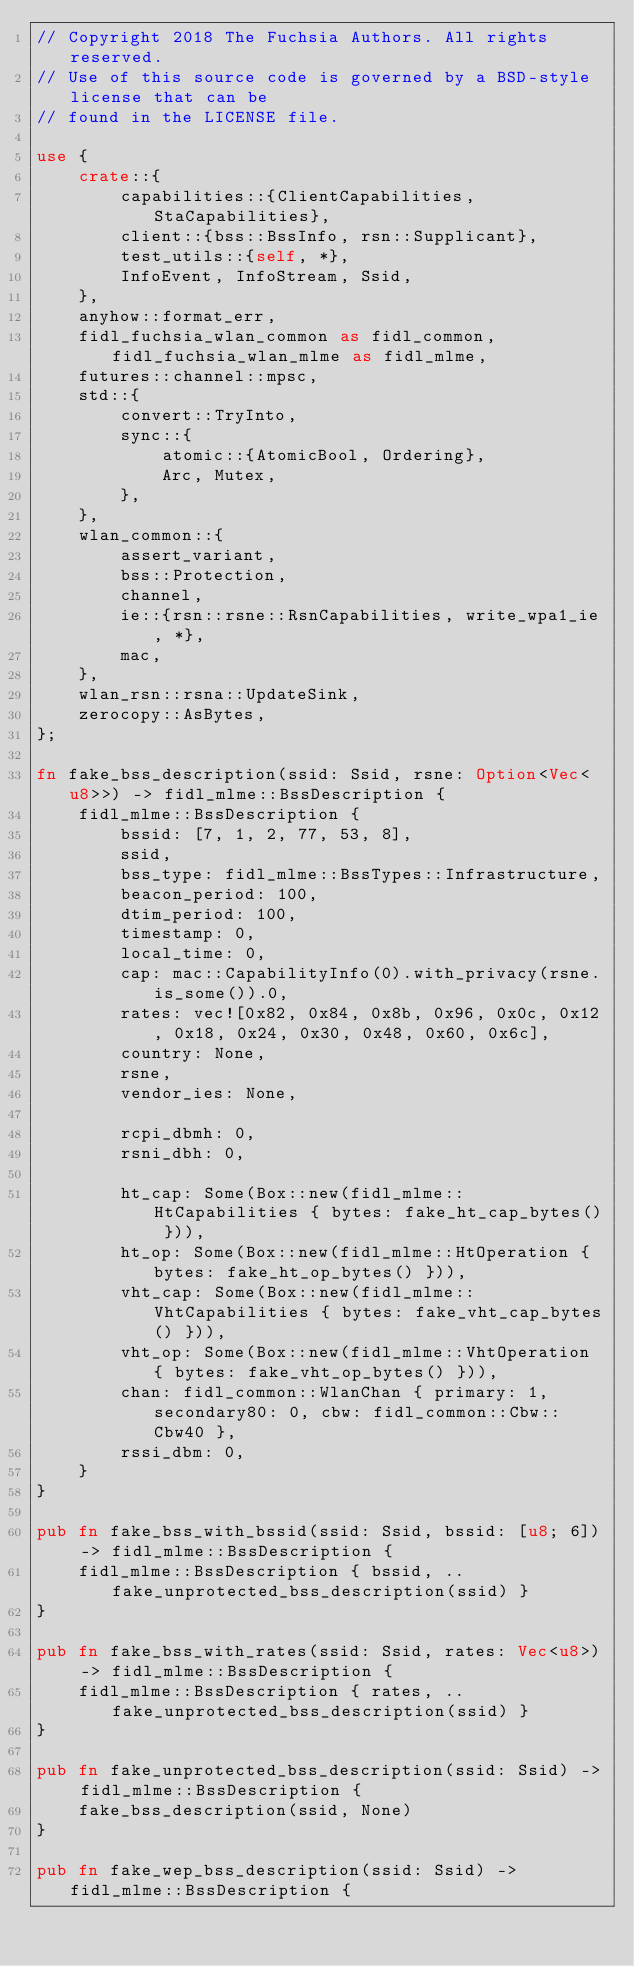<code> <loc_0><loc_0><loc_500><loc_500><_Rust_>// Copyright 2018 The Fuchsia Authors. All rights reserved.
// Use of this source code is governed by a BSD-style license that can be
// found in the LICENSE file.

use {
    crate::{
        capabilities::{ClientCapabilities, StaCapabilities},
        client::{bss::BssInfo, rsn::Supplicant},
        test_utils::{self, *},
        InfoEvent, InfoStream, Ssid,
    },
    anyhow::format_err,
    fidl_fuchsia_wlan_common as fidl_common, fidl_fuchsia_wlan_mlme as fidl_mlme,
    futures::channel::mpsc,
    std::{
        convert::TryInto,
        sync::{
            atomic::{AtomicBool, Ordering},
            Arc, Mutex,
        },
    },
    wlan_common::{
        assert_variant,
        bss::Protection,
        channel,
        ie::{rsn::rsne::RsnCapabilities, write_wpa1_ie, *},
        mac,
    },
    wlan_rsn::rsna::UpdateSink,
    zerocopy::AsBytes,
};

fn fake_bss_description(ssid: Ssid, rsne: Option<Vec<u8>>) -> fidl_mlme::BssDescription {
    fidl_mlme::BssDescription {
        bssid: [7, 1, 2, 77, 53, 8],
        ssid,
        bss_type: fidl_mlme::BssTypes::Infrastructure,
        beacon_period: 100,
        dtim_period: 100,
        timestamp: 0,
        local_time: 0,
        cap: mac::CapabilityInfo(0).with_privacy(rsne.is_some()).0,
        rates: vec![0x82, 0x84, 0x8b, 0x96, 0x0c, 0x12, 0x18, 0x24, 0x30, 0x48, 0x60, 0x6c],
        country: None,
        rsne,
        vendor_ies: None,

        rcpi_dbmh: 0,
        rsni_dbh: 0,

        ht_cap: Some(Box::new(fidl_mlme::HtCapabilities { bytes: fake_ht_cap_bytes() })),
        ht_op: Some(Box::new(fidl_mlme::HtOperation { bytes: fake_ht_op_bytes() })),
        vht_cap: Some(Box::new(fidl_mlme::VhtCapabilities { bytes: fake_vht_cap_bytes() })),
        vht_op: Some(Box::new(fidl_mlme::VhtOperation { bytes: fake_vht_op_bytes() })),
        chan: fidl_common::WlanChan { primary: 1, secondary80: 0, cbw: fidl_common::Cbw::Cbw40 },
        rssi_dbm: 0,
    }
}

pub fn fake_bss_with_bssid(ssid: Ssid, bssid: [u8; 6]) -> fidl_mlme::BssDescription {
    fidl_mlme::BssDescription { bssid, ..fake_unprotected_bss_description(ssid) }
}

pub fn fake_bss_with_rates(ssid: Ssid, rates: Vec<u8>) -> fidl_mlme::BssDescription {
    fidl_mlme::BssDescription { rates, ..fake_unprotected_bss_description(ssid) }
}

pub fn fake_unprotected_bss_description(ssid: Ssid) -> fidl_mlme::BssDescription {
    fake_bss_description(ssid, None)
}

pub fn fake_wep_bss_description(ssid: Ssid) -> fidl_mlme::BssDescription {</code> 